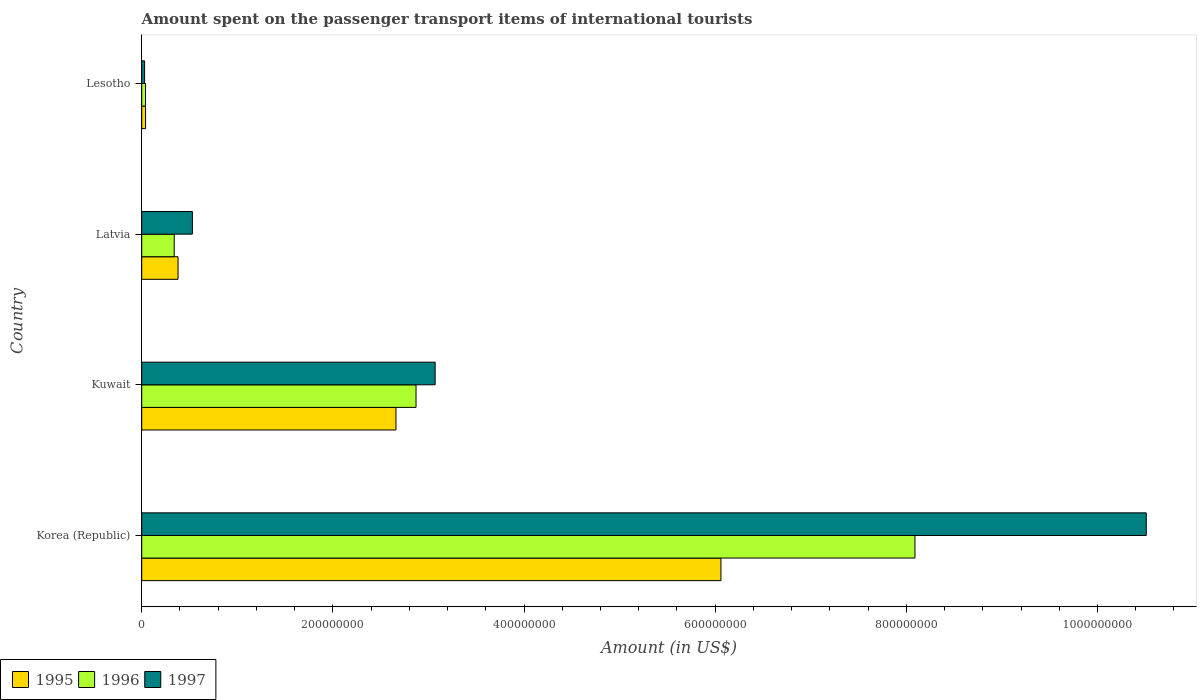How many different coloured bars are there?
Your answer should be very brief. 3. How many groups of bars are there?
Provide a succinct answer. 4. Are the number of bars on each tick of the Y-axis equal?
Your answer should be very brief. Yes. What is the label of the 1st group of bars from the top?
Your answer should be compact. Lesotho. Across all countries, what is the maximum amount spent on the passenger transport items of international tourists in 1997?
Ensure brevity in your answer.  1.05e+09. In which country was the amount spent on the passenger transport items of international tourists in 1995 maximum?
Your response must be concise. Korea (Republic). In which country was the amount spent on the passenger transport items of international tourists in 1996 minimum?
Your response must be concise. Lesotho. What is the total amount spent on the passenger transport items of international tourists in 1996 in the graph?
Make the answer very short. 1.13e+09. What is the difference between the amount spent on the passenger transport items of international tourists in 1995 in Latvia and that in Lesotho?
Keep it short and to the point. 3.40e+07. What is the difference between the amount spent on the passenger transport items of international tourists in 1995 in Lesotho and the amount spent on the passenger transport items of international tourists in 1996 in Korea (Republic)?
Provide a succinct answer. -8.05e+08. What is the average amount spent on the passenger transport items of international tourists in 1996 per country?
Your response must be concise. 2.84e+08. What is the difference between the amount spent on the passenger transport items of international tourists in 1995 and amount spent on the passenger transport items of international tourists in 1996 in Kuwait?
Your answer should be compact. -2.10e+07. What is the ratio of the amount spent on the passenger transport items of international tourists in 1997 in Latvia to that in Lesotho?
Ensure brevity in your answer.  17.67. Is the amount spent on the passenger transport items of international tourists in 1996 in Kuwait less than that in Lesotho?
Your answer should be compact. No. What is the difference between the highest and the second highest amount spent on the passenger transport items of international tourists in 1995?
Your answer should be very brief. 3.40e+08. What is the difference between the highest and the lowest amount spent on the passenger transport items of international tourists in 1996?
Keep it short and to the point. 8.05e+08. What does the 3rd bar from the top in Latvia represents?
Offer a very short reply. 1995. What does the 2nd bar from the bottom in Latvia represents?
Make the answer very short. 1996. How many bars are there?
Offer a terse response. 12. How many countries are there in the graph?
Offer a terse response. 4. What is the difference between two consecutive major ticks on the X-axis?
Give a very brief answer. 2.00e+08. How are the legend labels stacked?
Provide a succinct answer. Horizontal. What is the title of the graph?
Give a very brief answer. Amount spent on the passenger transport items of international tourists. What is the label or title of the X-axis?
Provide a succinct answer. Amount (in US$). What is the label or title of the Y-axis?
Provide a succinct answer. Country. What is the Amount (in US$) of 1995 in Korea (Republic)?
Provide a succinct answer. 6.06e+08. What is the Amount (in US$) in 1996 in Korea (Republic)?
Offer a very short reply. 8.09e+08. What is the Amount (in US$) in 1997 in Korea (Republic)?
Give a very brief answer. 1.05e+09. What is the Amount (in US$) of 1995 in Kuwait?
Keep it short and to the point. 2.66e+08. What is the Amount (in US$) of 1996 in Kuwait?
Your answer should be compact. 2.87e+08. What is the Amount (in US$) in 1997 in Kuwait?
Make the answer very short. 3.07e+08. What is the Amount (in US$) of 1995 in Latvia?
Offer a very short reply. 3.80e+07. What is the Amount (in US$) in 1996 in Latvia?
Provide a short and direct response. 3.40e+07. What is the Amount (in US$) of 1997 in Latvia?
Make the answer very short. 5.30e+07. What is the Amount (in US$) of 1996 in Lesotho?
Offer a very short reply. 4.00e+06. What is the Amount (in US$) in 1997 in Lesotho?
Your answer should be very brief. 3.00e+06. Across all countries, what is the maximum Amount (in US$) of 1995?
Offer a very short reply. 6.06e+08. Across all countries, what is the maximum Amount (in US$) in 1996?
Provide a short and direct response. 8.09e+08. Across all countries, what is the maximum Amount (in US$) in 1997?
Give a very brief answer. 1.05e+09. Across all countries, what is the minimum Amount (in US$) of 1995?
Your answer should be very brief. 4.00e+06. What is the total Amount (in US$) of 1995 in the graph?
Ensure brevity in your answer.  9.14e+08. What is the total Amount (in US$) in 1996 in the graph?
Offer a terse response. 1.13e+09. What is the total Amount (in US$) of 1997 in the graph?
Give a very brief answer. 1.41e+09. What is the difference between the Amount (in US$) of 1995 in Korea (Republic) and that in Kuwait?
Ensure brevity in your answer.  3.40e+08. What is the difference between the Amount (in US$) in 1996 in Korea (Republic) and that in Kuwait?
Offer a very short reply. 5.22e+08. What is the difference between the Amount (in US$) in 1997 in Korea (Republic) and that in Kuwait?
Keep it short and to the point. 7.44e+08. What is the difference between the Amount (in US$) in 1995 in Korea (Republic) and that in Latvia?
Offer a very short reply. 5.68e+08. What is the difference between the Amount (in US$) in 1996 in Korea (Republic) and that in Latvia?
Your response must be concise. 7.75e+08. What is the difference between the Amount (in US$) of 1997 in Korea (Republic) and that in Latvia?
Make the answer very short. 9.98e+08. What is the difference between the Amount (in US$) in 1995 in Korea (Republic) and that in Lesotho?
Offer a terse response. 6.02e+08. What is the difference between the Amount (in US$) of 1996 in Korea (Republic) and that in Lesotho?
Make the answer very short. 8.05e+08. What is the difference between the Amount (in US$) in 1997 in Korea (Republic) and that in Lesotho?
Make the answer very short. 1.05e+09. What is the difference between the Amount (in US$) in 1995 in Kuwait and that in Latvia?
Ensure brevity in your answer.  2.28e+08. What is the difference between the Amount (in US$) in 1996 in Kuwait and that in Latvia?
Keep it short and to the point. 2.53e+08. What is the difference between the Amount (in US$) in 1997 in Kuwait and that in Latvia?
Provide a short and direct response. 2.54e+08. What is the difference between the Amount (in US$) of 1995 in Kuwait and that in Lesotho?
Offer a very short reply. 2.62e+08. What is the difference between the Amount (in US$) of 1996 in Kuwait and that in Lesotho?
Give a very brief answer. 2.83e+08. What is the difference between the Amount (in US$) in 1997 in Kuwait and that in Lesotho?
Offer a very short reply. 3.04e+08. What is the difference between the Amount (in US$) of 1995 in Latvia and that in Lesotho?
Offer a very short reply. 3.40e+07. What is the difference between the Amount (in US$) of 1996 in Latvia and that in Lesotho?
Ensure brevity in your answer.  3.00e+07. What is the difference between the Amount (in US$) of 1995 in Korea (Republic) and the Amount (in US$) of 1996 in Kuwait?
Give a very brief answer. 3.19e+08. What is the difference between the Amount (in US$) in 1995 in Korea (Republic) and the Amount (in US$) in 1997 in Kuwait?
Make the answer very short. 2.99e+08. What is the difference between the Amount (in US$) in 1996 in Korea (Republic) and the Amount (in US$) in 1997 in Kuwait?
Your response must be concise. 5.02e+08. What is the difference between the Amount (in US$) in 1995 in Korea (Republic) and the Amount (in US$) in 1996 in Latvia?
Offer a very short reply. 5.72e+08. What is the difference between the Amount (in US$) in 1995 in Korea (Republic) and the Amount (in US$) in 1997 in Latvia?
Your answer should be compact. 5.53e+08. What is the difference between the Amount (in US$) in 1996 in Korea (Republic) and the Amount (in US$) in 1997 in Latvia?
Provide a succinct answer. 7.56e+08. What is the difference between the Amount (in US$) of 1995 in Korea (Republic) and the Amount (in US$) of 1996 in Lesotho?
Offer a very short reply. 6.02e+08. What is the difference between the Amount (in US$) in 1995 in Korea (Republic) and the Amount (in US$) in 1997 in Lesotho?
Make the answer very short. 6.03e+08. What is the difference between the Amount (in US$) in 1996 in Korea (Republic) and the Amount (in US$) in 1997 in Lesotho?
Provide a succinct answer. 8.06e+08. What is the difference between the Amount (in US$) in 1995 in Kuwait and the Amount (in US$) in 1996 in Latvia?
Your answer should be very brief. 2.32e+08. What is the difference between the Amount (in US$) in 1995 in Kuwait and the Amount (in US$) in 1997 in Latvia?
Ensure brevity in your answer.  2.13e+08. What is the difference between the Amount (in US$) of 1996 in Kuwait and the Amount (in US$) of 1997 in Latvia?
Offer a terse response. 2.34e+08. What is the difference between the Amount (in US$) in 1995 in Kuwait and the Amount (in US$) in 1996 in Lesotho?
Your answer should be compact. 2.62e+08. What is the difference between the Amount (in US$) in 1995 in Kuwait and the Amount (in US$) in 1997 in Lesotho?
Give a very brief answer. 2.63e+08. What is the difference between the Amount (in US$) in 1996 in Kuwait and the Amount (in US$) in 1997 in Lesotho?
Keep it short and to the point. 2.84e+08. What is the difference between the Amount (in US$) in 1995 in Latvia and the Amount (in US$) in 1996 in Lesotho?
Your answer should be very brief. 3.40e+07. What is the difference between the Amount (in US$) in 1995 in Latvia and the Amount (in US$) in 1997 in Lesotho?
Provide a short and direct response. 3.50e+07. What is the difference between the Amount (in US$) of 1996 in Latvia and the Amount (in US$) of 1997 in Lesotho?
Your response must be concise. 3.10e+07. What is the average Amount (in US$) of 1995 per country?
Your response must be concise. 2.28e+08. What is the average Amount (in US$) of 1996 per country?
Ensure brevity in your answer.  2.84e+08. What is the average Amount (in US$) in 1997 per country?
Provide a succinct answer. 3.54e+08. What is the difference between the Amount (in US$) in 1995 and Amount (in US$) in 1996 in Korea (Republic)?
Offer a very short reply. -2.03e+08. What is the difference between the Amount (in US$) in 1995 and Amount (in US$) in 1997 in Korea (Republic)?
Give a very brief answer. -4.45e+08. What is the difference between the Amount (in US$) in 1996 and Amount (in US$) in 1997 in Korea (Republic)?
Your answer should be very brief. -2.42e+08. What is the difference between the Amount (in US$) of 1995 and Amount (in US$) of 1996 in Kuwait?
Offer a terse response. -2.10e+07. What is the difference between the Amount (in US$) of 1995 and Amount (in US$) of 1997 in Kuwait?
Offer a very short reply. -4.10e+07. What is the difference between the Amount (in US$) in 1996 and Amount (in US$) in 1997 in Kuwait?
Your answer should be very brief. -2.00e+07. What is the difference between the Amount (in US$) of 1995 and Amount (in US$) of 1997 in Latvia?
Your answer should be very brief. -1.50e+07. What is the difference between the Amount (in US$) in 1996 and Amount (in US$) in 1997 in Latvia?
Your answer should be compact. -1.90e+07. What is the difference between the Amount (in US$) in 1995 and Amount (in US$) in 1996 in Lesotho?
Offer a very short reply. 0. What is the difference between the Amount (in US$) in 1995 and Amount (in US$) in 1997 in Lesotho?
Keep it short and to the point. 1.00e+06. What is the difference between the Amount (in US$) in 1996 and Amount (in US$) in 1997 in Lesotho?
Make the answer very short. 1.00e+06. What is the ratio of the Amount (in US$) of 1995 in Korea (Republic) to that in Kuwait?
Provide a succinct answer. 2.28. What is the ratio of the Amount (in US$) of 1996 in Korea (Republic) to that in Kuwait?
Provide a succinct answer. 2.82. What is the ratio of the Amount (in US$) in 1997 in Korea (Republic) to that in Kuwait?
Your response must be concise. 3.42. What is the ratio of the Amount (in US$) in 1995 in Korea (Republic) to that in Latvia?
Offer a very short reply. 15.95. What is the ratio of the Amount (in US$) in 1996 in Korea (Republic) to that in Latvia?
Make the answer very short. 23.79. What is the ratio of the Amount (in US$) in 1997 in Korea (Republic) to that in Latvia?
Offer a very short reply. 19.83. What is the ratio of the Amount (in US$) in 1995 in Korea (Republic) to that in Lesotho?
Offer a terse response. 151.5. What is the ratio of the Amount (in US$) in 1996 in Korea (Republic) to that in Lesotho?
Give a very brief answer. 202.25. What is the ratio of the Amount (in US$) in 1997 in Korea (Republic) to that in Lesotho?
Provide a succinct answer. 350.33. What is the ratio of the Amount (in US$) in 1996 in Kuwait to that in Latvia?
Your answer should be very brief. 8.44. What is the ratio of the Amount (in US$) in 1997 in Kuwait to that in Latvia?
Your answer should be compact. 5.79. What is the ratio of the Amount (in US$) of 1995 in Kuwait to that in Lesotho?
Your answer should be compact. 66.5. What is the ratio of the Amount (in US$) in 1996 in Kuwait to that in Lesotho?
Offer a very short reply. 71.75. What is the ratio of the Amount (in US$) of 1997 in Kuwait to that in Lesotho?
Ensure brevity in your answer.  102.33. What is the ratio of the Amount (in US$) in 1995 in Latvia to that in Lesotho?
Your answer should be very brief. 9.5. What is the ratio of the Amount (in US$) in 1997 in Latvia to that in Lesotho?
Provide a short and direct response. 17.67. What is the difference between the highest and the second highest Amount (in US$) in 1995?
Provide a succinct answer. 3.40e+08. What is the difference between the highest and the second highest Amount (in US$) in 1996?
Ensure brevity in your answer.  5.22e+08. What is the difference between the highest and the second highest Amount (in US$) of 1997?
Make the answer very short. 7.44e+08. What is the difference between the highest and the lowest Amount (in US$) of 1995?
Your response must be concise. 6.02e+08. What is the difference between the highest and the lowest Amount (in US$) of 1996?
Make the answer very short. 8.05e+08. What is the difference between the highest and the lowest Amount (in US$) of 1997?
Your answer should be very brief. 1.05e+09. 